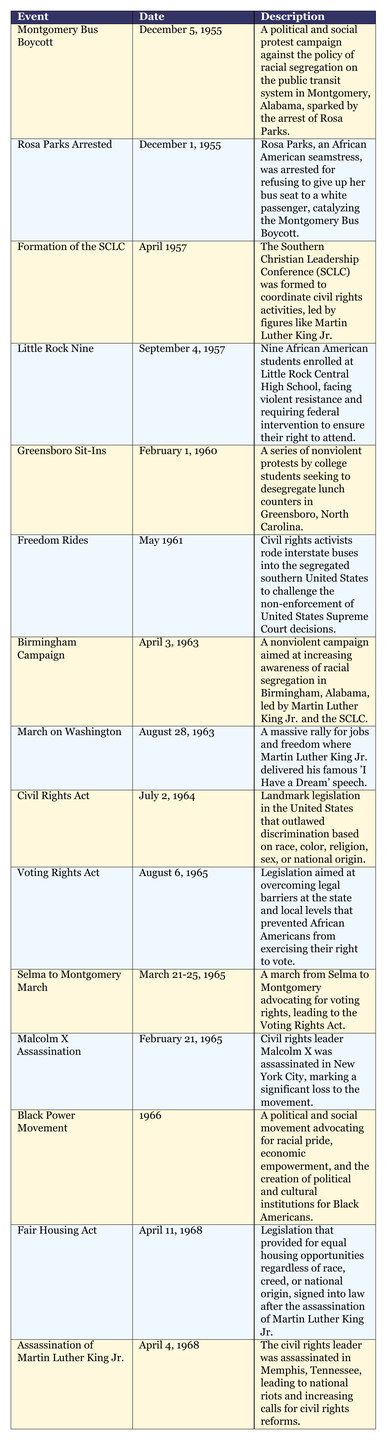What event occurred on December 1, 1955? The table lists "Rosa Parks Arrested" as the event that occurred on that date, which describes her arrest for refusing to give up her bus seat to a white passenger.
Answer: Rosa Parks Arrested How many events listed in the table occurred in the year 1965? The table shows two events in 1965: the "Voting Rights Act" and the "Selma to Montgomery March." Thus, the total count is two.
Answer: 2 Was the "Civil Rights Act" passed before or after Martin Luther King Jr.'s assassination? By checking the dates, the "Civil Rights Act" was passed on July 2, 1964, while Martin Luther King Jr. was assassinated on April 4, 1968, which means it was before.
Answer: Before What is the date of the "Birmingham Campaign"? The table provides the date for the "Birmingham Campaign" as April 3, 1963.
Answer: April 3, 1963 Which event involved the desegregation of lunch counters and when did it start? The "Greensboro Sit-Ins" involved the desegregation of lunch counters and started on February 1, 1960.
Answer: Greensboro Sit-Ins, February 1, 1960 How many years passed between the "Little Rock Nine" event and the "Black Power Movement"? The "Little Rock Nine" event was on September 4, 1957, and the "Black Power Movement" began in 1966. To find the difference: 1966 - 1957 = 9 years.
Answer: 9 years What significant event happened on August 28, 1963? On this date, the "March on Washington" took place, which was a huge rally where Martin Luther King Jr. delivered the "I Have a Dream" speech.
Answer: March on Washington Which event occurred immediately after Rosa Parks' arrest? The "Montgomery Bus Boycott" occurred just days after Rosa Parks' arrest on December 1, 1955, starting on December 5, 1955.
Answer: Montgomery Bus Boycott What was the main accomplishment of the "Voting Rights Act"? The "Voting Rights Act" aimed to eliminate the legal barriers preventing African Americans from exercising their right to vote.
Answer: Elimination of voting barriers How many months were there between the "Formation of the SCLC" and the "March on Washington"? The "Formation of the SCLC" was in April 1957 and the "March on Washington" occurred in August 1963. Counting months: from April 1957 to April 1963 is 6 years or 72 months, plus 4 months from April to August makes it 76 months total.
Answer: 76 months 